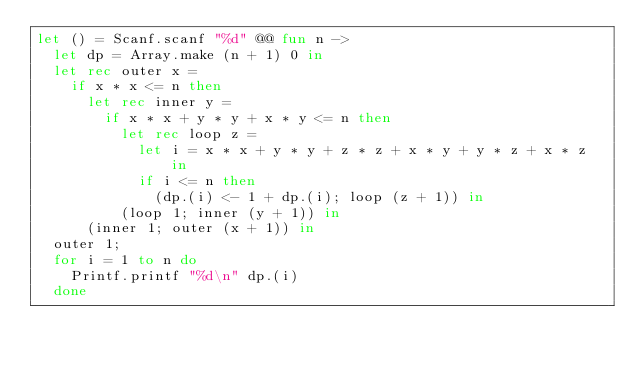<code> <loc_0><loc_0><loc_500><loc_500><_OCaml_>let () = Scanf.scanf "%d" @@ fun n ->
  let dp = Array.make (n + 1) 0 in
  let rec outer x =
    if x * x <= n then
      let rec inner y =
        if x * x + y * y + x * y <= n then
          let rec loop z =
            let i = x * x + y * y + z * z + x * y + y * z + x * z in
            if i <= n then
              (dp.(i) <- 1 + dp.(i); loop (z + 1)) in
          (loop 1; inner (y + 1)) in
      (inner 1; outer (x + 1)) in
  outer 1;
  for i = 1 to n do
    Printf.printf "%d\n" dp.(i)
  done</code> 